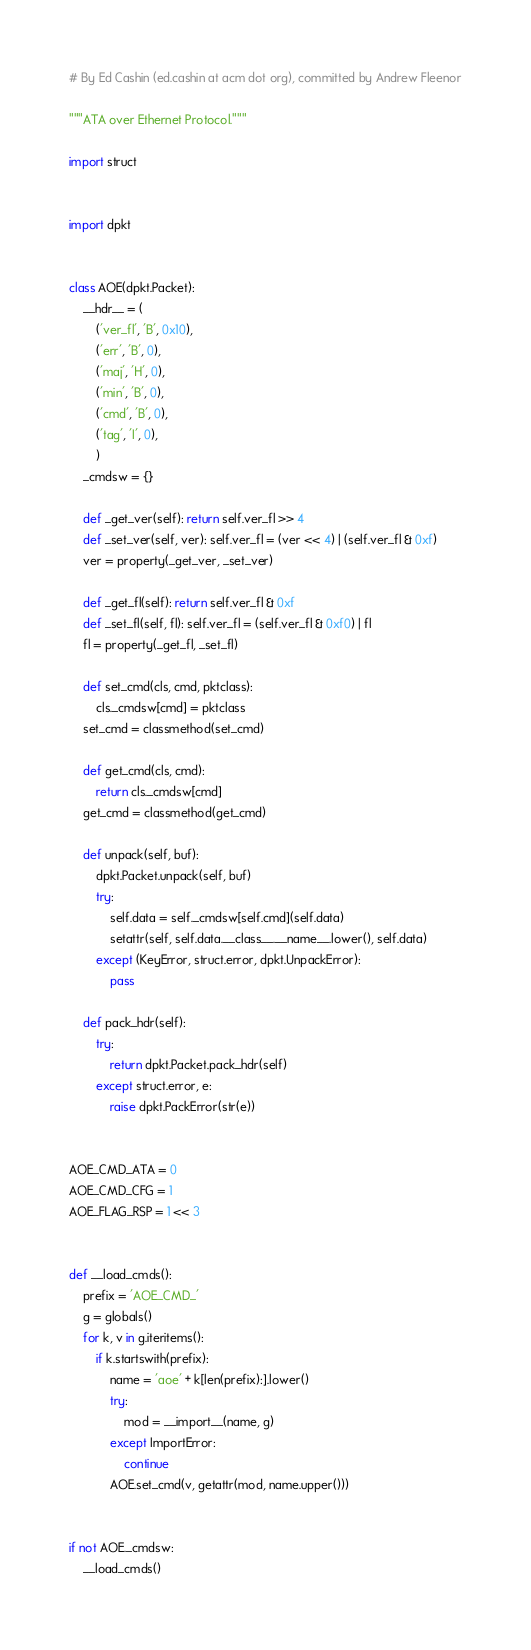Convert code to text. <code><loc_0><loc_0><loc_500><loc_500><_Python_># By Ed Cashin (ed.cashin at acm dot org), committed by Andrew Fleenor

"""ATA over Ethernet Protocol."""

import struct


import dpkt


class AOE(dpkt.Packet):
    __hdr__ = (
        ('ver_fl', 'B', 0x10),
        ('err', 'B', 0),
        ('maj', 'H', 0),
        ('min', 'B', 0),
        ('cmd', 'B', 0),
        ('tag', 'I', 0),
        )
    _cmdsw = {}
    
    def _get_ver(self): return self.ver_fl >> 4
    def _set_ver(self, ver): self.ver_fl = (ver << 4) | (self.ver_fl & 0xf)
    ver = property(_get_ver, _set_ver)

    def _get_fl(self): return self.ver_fl & 0xf
    def _set_fl(self, fl): self.ver_fl = (self.ver_fl & 0xf0) | fl
    fl = property(_get_fl, _set_fl)

    def set_cmd(cls, cmd, pktclass):
        cls._cmdsw[cmd] = pktclass
    set_cmd = classmethod(set_cmd)

    def get_cmd(cls, cmd):
        return cls._cmdsw[cmd]
    get_cmd = classmethod(get_cmd)

    def unpack(self, buf):
        dpkt.Packet.unpack(self, buf)
        try:
            self.data = self._cmdsw[self.cmd](self.data)
            setattr(self, self.data.__class__.__name__.lower(), self.data)
        except (KeyError, struct.error, dpkt.UnpackError):
            pass

    def pack_hdr(self):
        try:
            return dpkt.Packet.pack_hdr(self)
        except struct.error, e:
            raise dpkt.PackError(str(e))


AOE_CMD_ATA = 0
AOE_CMD_CFG = 1
AOE_FLAG_RSP = 1 << 3


def __load_cmds():
    prefix = 'AOE_CMD_'
    g = globals()
    for k, v in g.iteritems():
        if k.startswith(prefix):
            name = 'aoe' + k[len(prefix):].lower()
            try:
                mod = __import__(name, g)
            except ImportError:
                continue
            AOE.set_cmd(v, getattr(mod, name.upper()))


if not AOE._cmdsw:
    __load_cmds()
</code> 